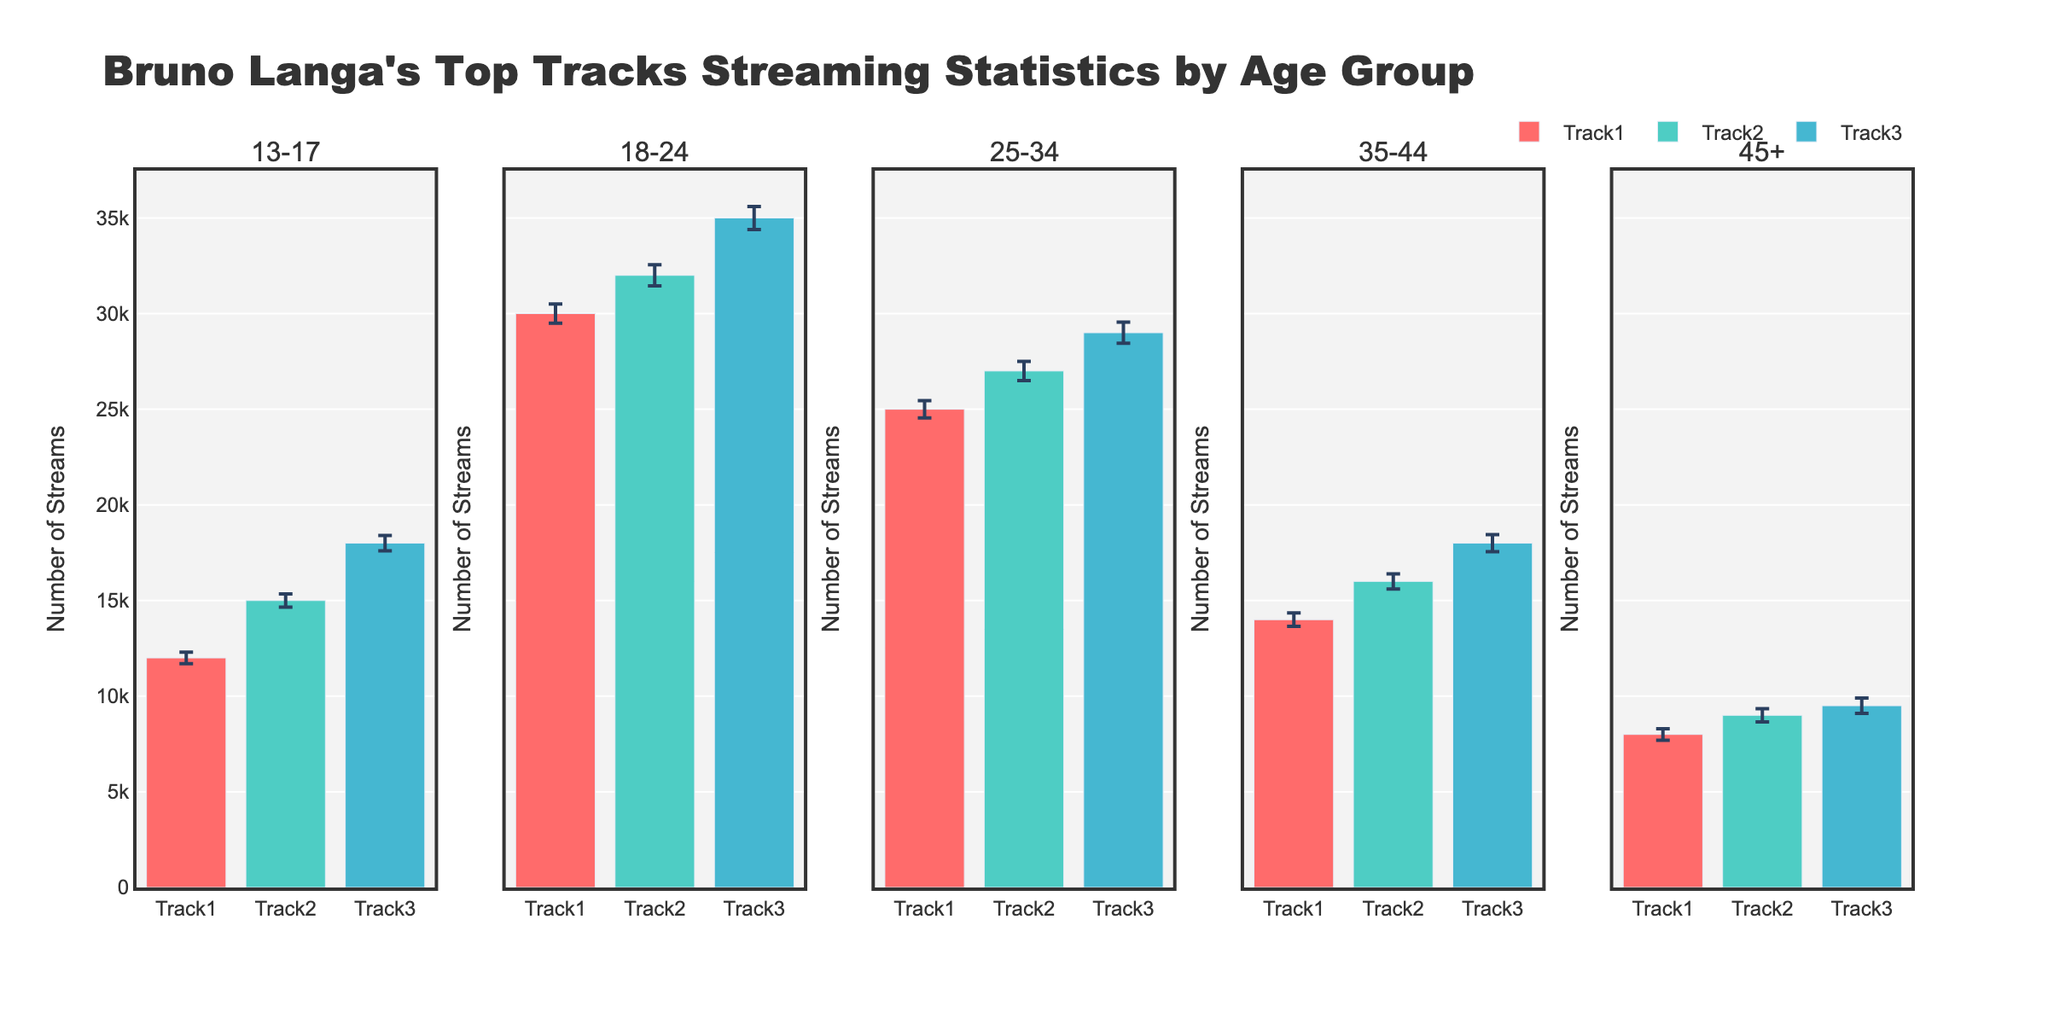What's the title of the figure? The title is typically displayed at the top of the figure. Here, it states, "Bruno Langa's Top Tracks Streaming Statistics by Age Group".
Answer: Bruno Langa's Top Tracks Streaming Statistics by Age Group Which track has the highest number of streams for the age group 18-24? Look at the subplot labeled "18-24" and identify which track has the tallest bar. Track3 has the highest bar with streams of 35,000.
Answer: Track3 What is the error margin for Track1 in the age group 35-44? Look at the subplot labeled "35-44" and find Track1. The error margin is shown as an uncertainty bar. For Track1, it is given as 350.
Answer: 350 Among all age groups, which age group streams Track2 the most? Compare the heights of the bars representing Track2 across all subplots. The age group 18-24 has the highest number of streams for Track2, with 32,000 streams.
Answer: 18-24 Calculate the total number of streams for Track1 across all age groups. Sum the number of streams for Track1 in each age group: 12000 (13-17) + 30000 (18-24) + 25000 (25-34) + 14000 (35-44) + 8000 (45+). Total = 89000.
Answer: 89000 Which track has the smallest error margin in the age group 25-34? Look at the subplot labeled "25-34" and compare the error bars for all tracks. Track1 has the smallest error margin of 450.
Answer: Track1 Does Track3 have more streams in the age group 13-17 or 25-34? Check the subplots for the age groups 13-17 and 25-34 and compare the heights of the bars for Track3. Track3 has 18,000 streams in 13-17 and 29,000 streams in 25-34.
Answer: 25-34 What is the average number of streams for Track2 across all age groups? Sum the number of streams for Track2 across all age groups and divide by the number of age groups. (15000 + 32000 + 27000 + 16000 + 9000) / 5 = 19800.
Answer: 19800 Which age group has the least number of streams for Track3? Look at the subplots for each age group and identify which one has the shortest bar for Track3. The age group 45+ has the least with 9500 streams.
Answer: 45+ For the age group 13-17, is there any track whose error margin is more than 400? Check the error margins for all tracks in the subplot labeled 13-17. Track3 has an error margin of 400, which does not exceed 400, so no track has an error margin greater than 400.
Answer: No 